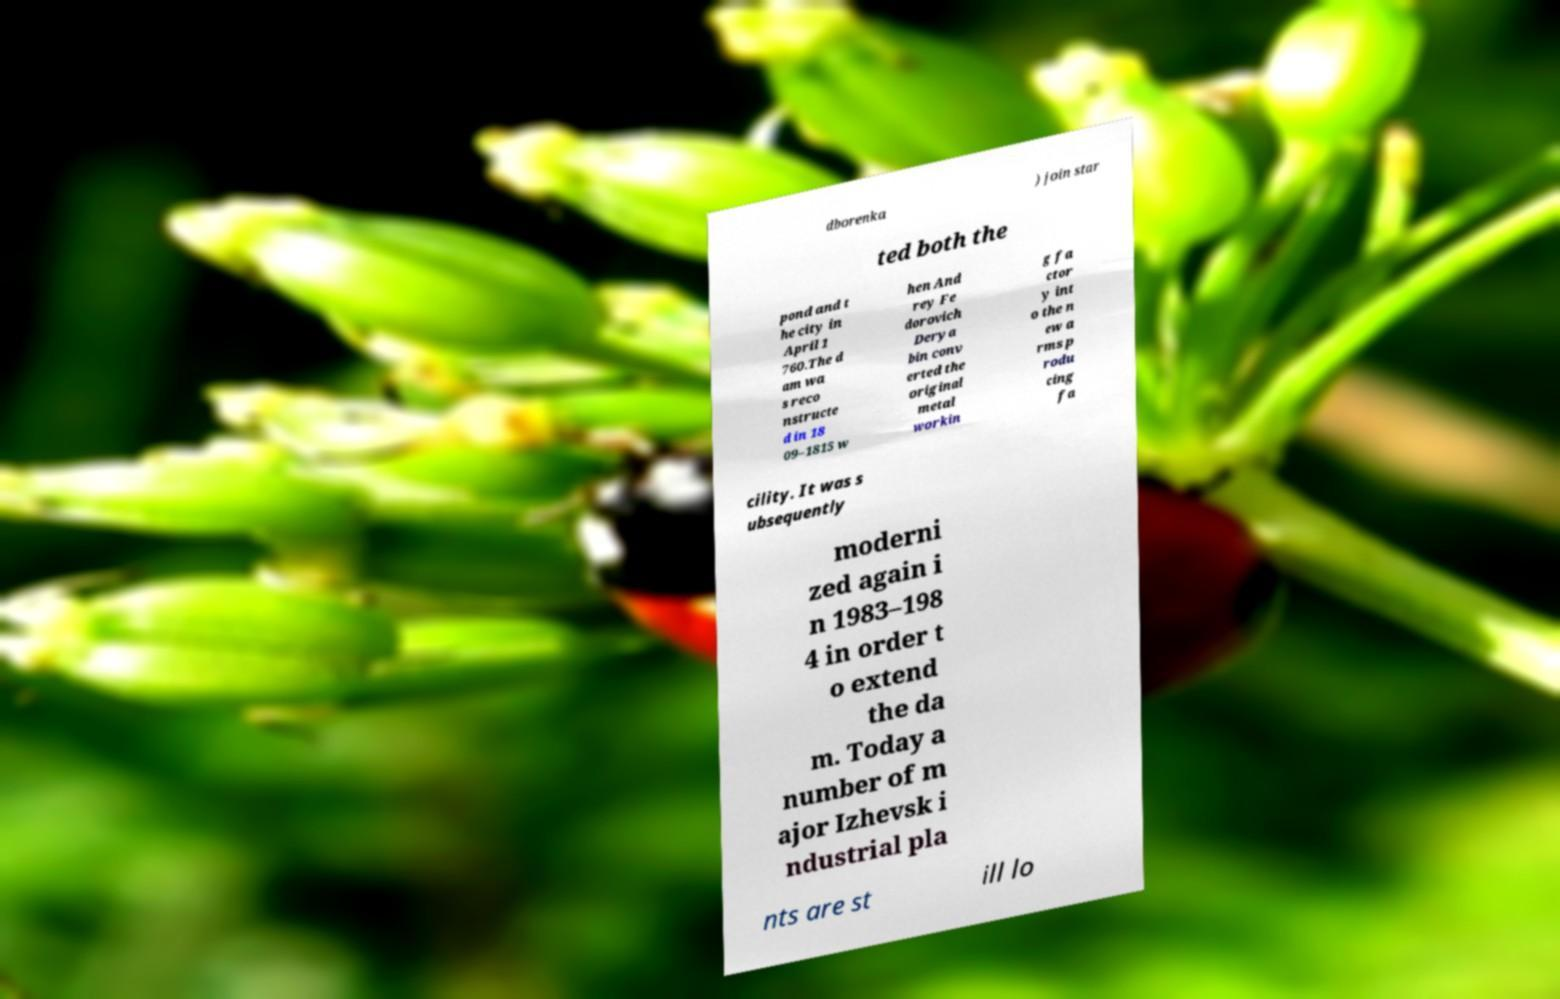Please read and relay the text visible in this image. What does it say? dborenka ) join star ted both the pond and t he city in April 1 760.The d am wa s reco nstructe d in 18 09–1815 w hen And rey Fe dorovich Derya bin conv erted the original metal workin g fa ctor y int o the n ew a rms p rodu cing fa cility. It was s ubsequently moderni zed again i n 1983–198 4 in order t o extend the da m. Today a number of m ajor Izhevsk i ndustrial pla nts are st ill lo 